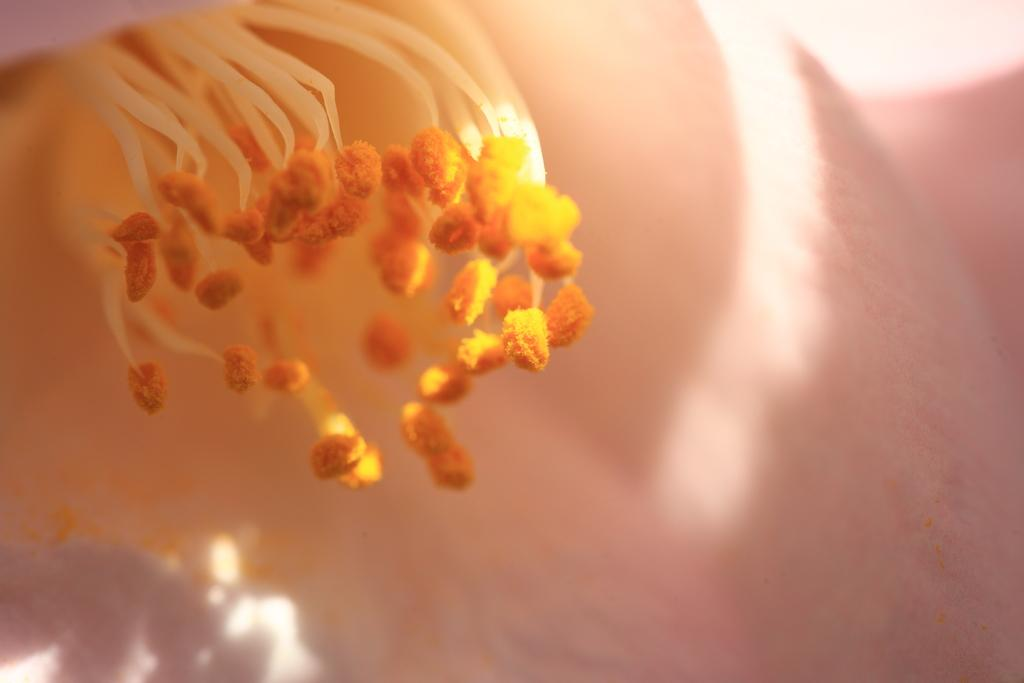What is the main subject of the image? There is a flower in the image. Can you describe the background of the image? The background of the image is blurry. What type of skin condition can be seen on the flower in the image? There is no skin condition present on the flower in the image, as flowers do not have skin. How many cacti are visible in the image? There are no cacti present in the image; it features a flower. 